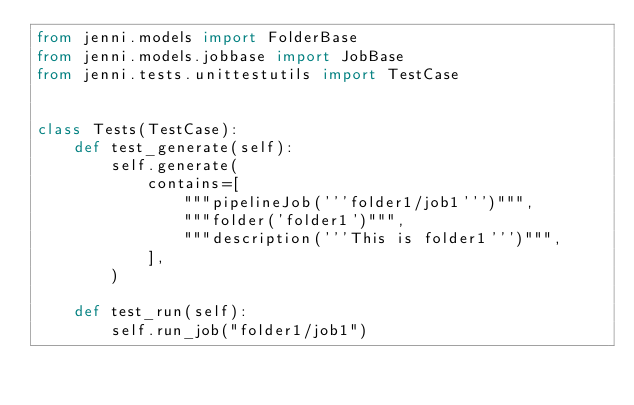Convert code to text. <code><loc_0><loc_0><loc_500><loc_500><_Python_>from jenni.models import FolderBase
from jenni.models.jobbase import JobBase
from jenni.tests.unittestutils import TestCase


class Tests(TestCase):
    def test_generate(self):
        self.generate(
            contains=[
                """pipelineJob('''folder1/job1''')""",
                """folder('folder1')""",
                """description('''This is folder1''')""",
            ],
        )

    def test_run(self):
        self.run_job("folder1/job1")
</code> 